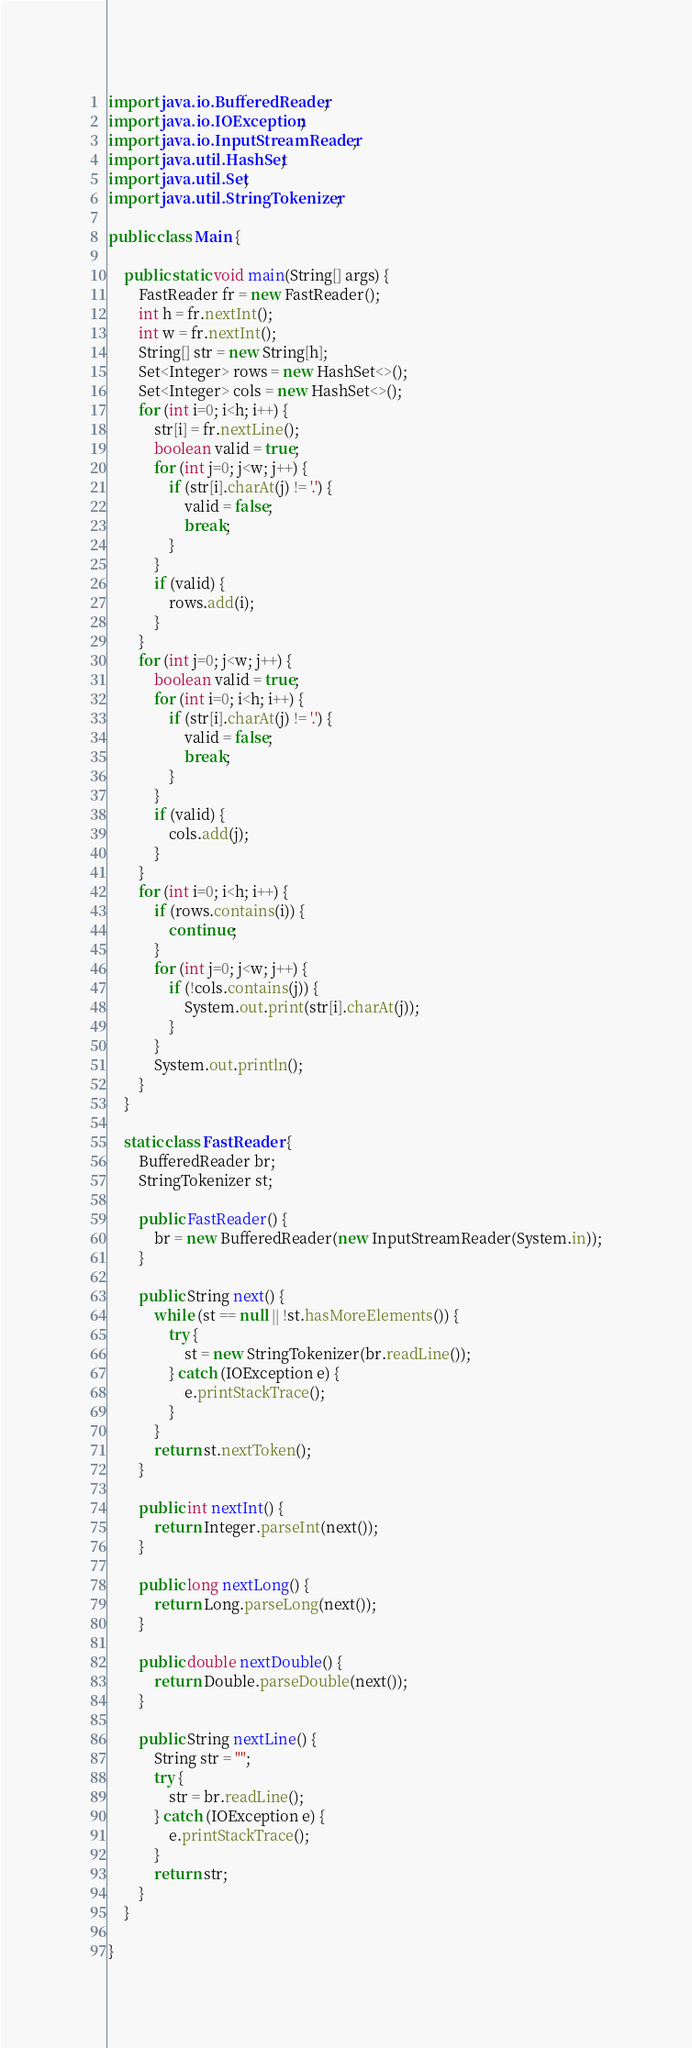Convert code to text. <code><loc_0><loc_0><loc_500><loc_500><_Java_>import java.io.BufferedReader;
import java.io.IOException;
import java.io.InputStreamReader;
import java.util.HashSet;
import java.util.Set;
import java.util.StringTokenizer;

public class Main {
	
	public static void main(String[] args) {
		FastReader fr = new FastReader();
		int h = fr.nextInt();
		int w = fr.nextInt();
		String[] str = new String[h];
		Set<Integer> rows = new HashSet<>();
		Set<Integer> cols = new HashSet<>();
		for (int i=0; i<h; i++) {
			str[i] = fr.nextLine();
			boolean valid = true;
			for (int j=0; j<w; j++) {
				if (str[i].charAt(j) != '.') {
					valid = false;
					break;
				}
			}
			if (valid) {
				rows.add(i);
			}
		}
		for (int j=0; j<w; j++) {
			boolean valid = true;
			for (int i=0; i<h; i++) {
				if (str[i].charAt(j) != '.') {
					valid = false;
					break;
				}
			}
			if (valid) {
				cols.add(j);
			}
		}
		for (int i=0; i<h; i++) {
			if (rows.contains(i)) {
				continue;
			}
			for (int j=0; j<w; j++) {
				if (!cols.contains(j)) {
					System.out.print(str[i].charAt(j));
				}
			}
			System.out.println();
		}
	}
	
	static class FastReader {
		BufferedReader br;
		StringTokenizer st;

		public FastReader() {
			br = new BufferedReader(new InputStreamReader(System.in));
		}

		public String next() {
			while (st == null || !st.hasMoreElements()) {
				try {
					st = new StringTokenizer(br.readLine());
				} catch (IOException e) {
					e.printStackTrace();
				}
			}
			return st.nextToken();
		}

		public int nextInt() {
			return Integer.parseInt(next());
		}

		public long nextLong() {
			return Long.parseLong(next());
		}

		public double nextDouble() {
			return Double.parseDouble(next());
		}

		public String nextLine() {
			String str = "";
			try {
				str = br.readLine();
			} catch (IOException e) {
				e.printStackTrace();
			}
			return str;
		}
	}

}
</code> 